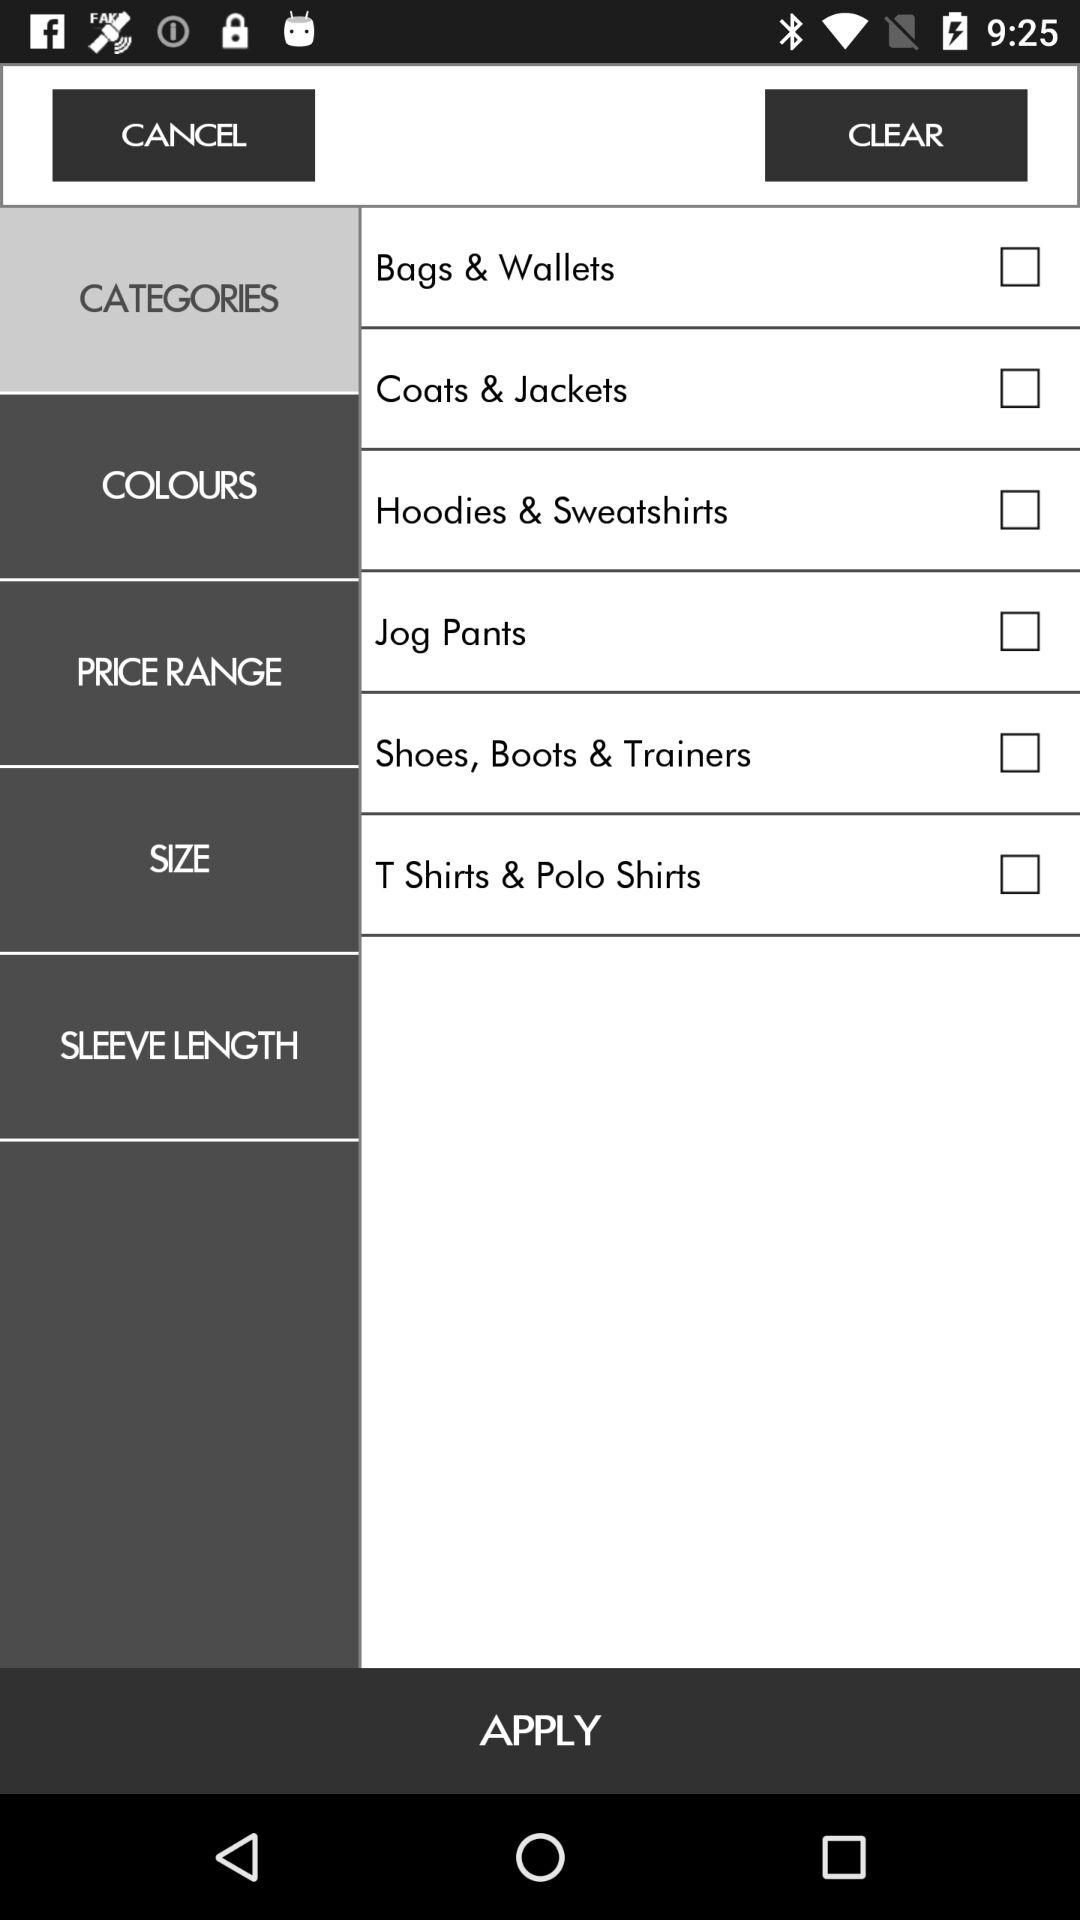What is the status of the "Jog Pants"? The status is "off". 